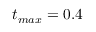<formula> <loc_0><loc_0><loc_500><loc_500>t _ { \max } = 0 . 4</formula> 